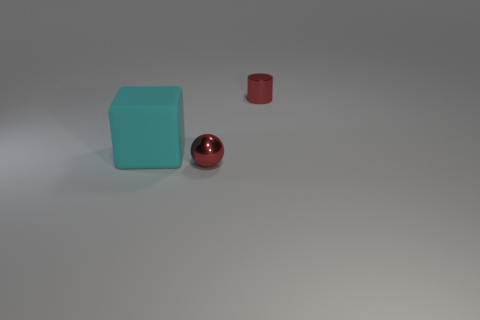What number of cyan cubes have the same material as the cylinder?
Ensure brevity in your answer.  0. Is there a rubber object that is right of the small red metallic object behind the small red metallic object in front of the small metallic cylinder?
Keep it short and to the point. No. The large thing is what shape?
Ensure brevity in your answer.  Cube. Is the material of the small red thing that is in front of the cube the same as the small thing that is behind the metallic sphere?
Provide a succinct answer. Yes. What number of small shiny objects have the same color as the large block?
Provide a short and direct response. 0. What shape is the object that is both in front of the tiny red cylinder and on the right side of the large cyan rubber cube?
Give a very brief answer. Sphere. What is the color of the thing that is both on the right side of the rubber object and left of the tiny red cylinder?
Make the answer very short. Red. Is the number of balls in front of the red ball greater than the number of cyan matte blocks behind the red metal cylinder?
Offer a very short reply. No. There is a shiny thing that is behind the cyan rubber cube; what color is it?
Keep it short and to the point. Red. There is a red thing that is in front of the block; does it have the same shape as the red metal object behind the matte block?
Your answer should be compact. No. 